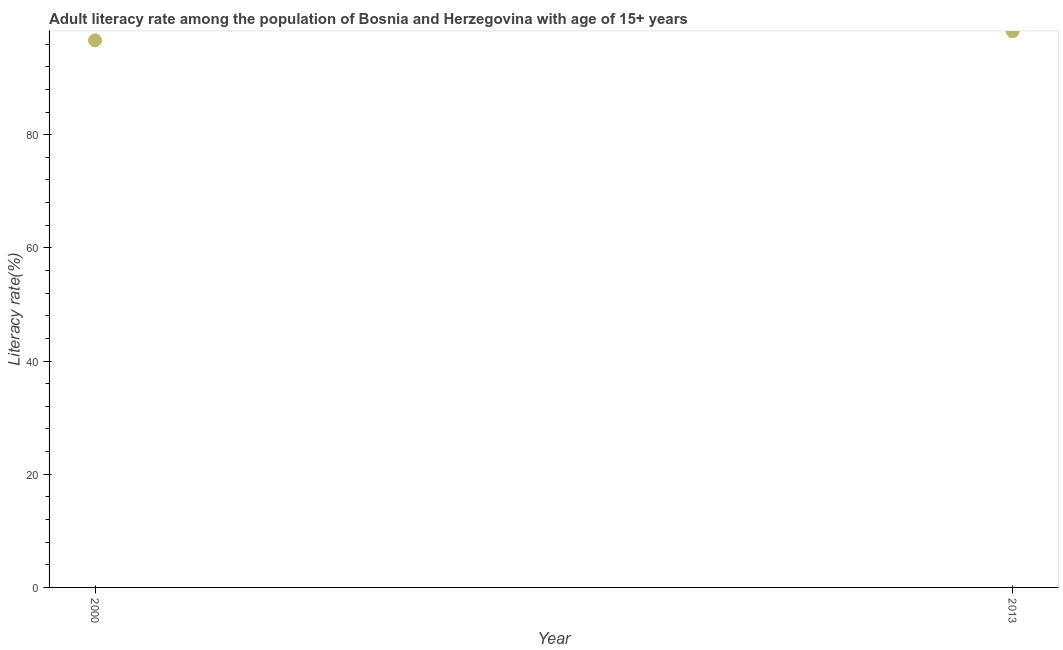What is the adult literacy rate in 2000?
Ensure brevity in your answer.  96.66. Across all years, what is the maximum adult literacy rate?
Offer a very short reply. 98.26. Across all years, what is the minimum adult literacy rate?
Your answer should be compact. 96.66. In which year was the adult literacy rate minimum?
Give a very brief answer. 2000. What is the sum of the adult literacy rate?
Give a very brief answer. 194.93. What is the difference between the adult literacy rate in 2000 and 2013?
Your answer should be very brief. -1.6. What is the average adult literacy rate per year?
Make the answer very short. 97.46. What is the median adult literacy rate?
Provide a short and direct response. 97.46. What is the ratio of the adult literacy rate in 2000 to that in 2013?
Your answer should be compact. 0.98. Is the adult literacy rate in 2000 less than that in 2013?
Your answer should be compact. Yes. In how many years, is the adult literacy rate greater than the average adult literacy rate taken over all years?
Provide a succinct answer. 1. What is the difference between two consecutive major ticks on the Y-axis?
Keep it short and to the point. 20. Are the values on the major ticks of Y-axis written in scientific E-notation?
Offer a very short reply. No. What is the title of the graph?
Your answer should be compact. Adult literacy rate among the population of Bosnia and Herzegovina with age of 15+ years. What is the label or title of the X-axis?
Offer a very short reply. Year. What is the label or title of the Y-axis?
Your response must be concise. Literacy rate(%). What is the Literacy rate(%) in 2000?
Keep it short and to the point. 96.66. What is the Literacy rate(%) in 2013?
Provide a short and direct response. 98.26. What is the difference between the Literacy rate(%) in 2000 and 2013?
Provide a succinct answer. -1.6. What is the ratio of the Literacy rate(%) in 2000 to that in 2013?
Offer a terse response. 0.98. 